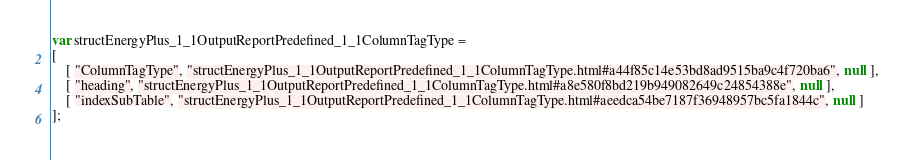<code> <loc_0><loc_0><loc_500><loc_500><_JavaScript_>var structEnergyPlus_1_1OutputReportPredefined_1_1ColumnTagType =
[
    [ "ColumnTagType", "structEnergyPlus_1_1OutputReportPredefined_1_1ColumnTagType.html#a44f85c14e53bd8ad9515ba9c4f720ba6", null ],
    [ "heading", "structEnergyPlus_1_1OutputReportPredefined_1_1ColumnTagType.html#a8e580f8bd219b949082649c24854388e", null ],
    [ "indexSubTable", "structEnergyPlus_1_1OutputReportPredefined_1_1ColumnTagType.html#aeedca54be7187f36948957bc5fa1844c", null ]
];</code> 